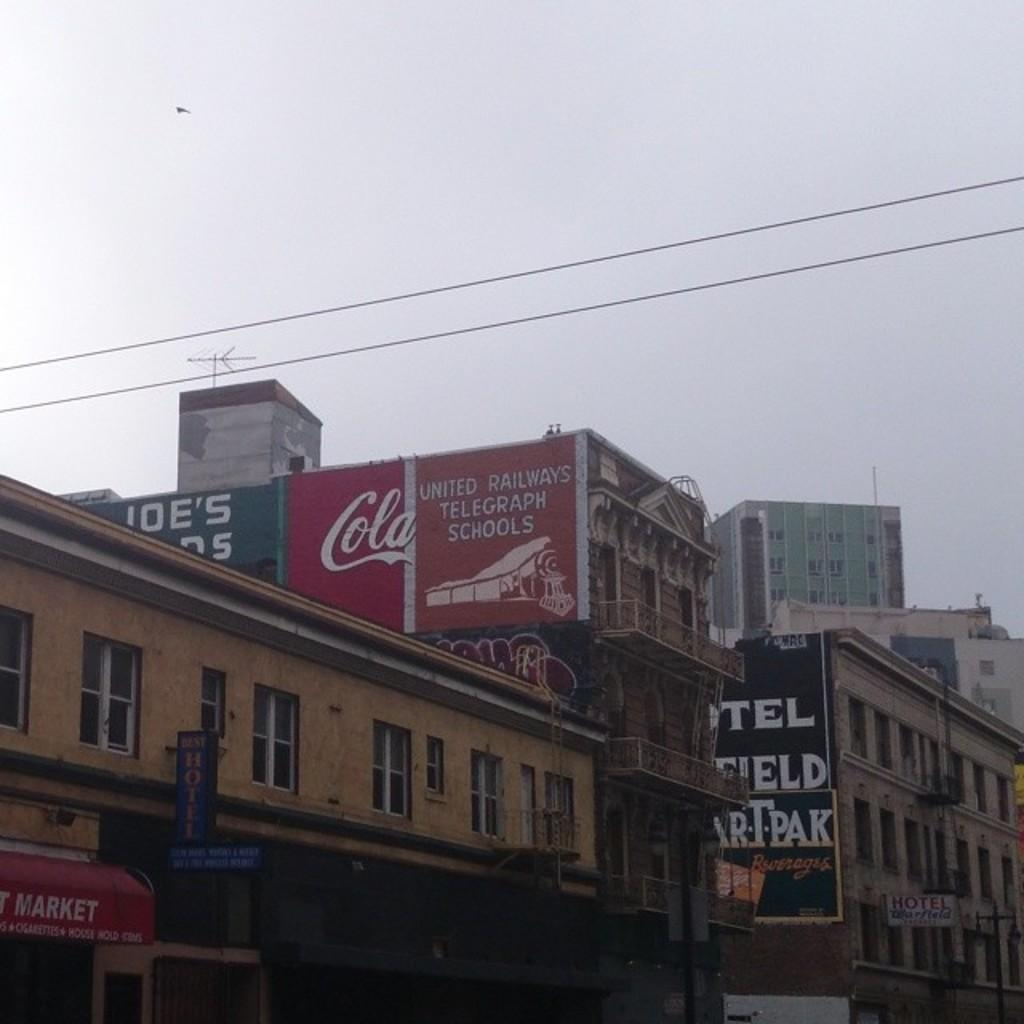<image>
Render a clear and concise summary of the photo. A large building has ads painted on it that say Cola and United Railways. 